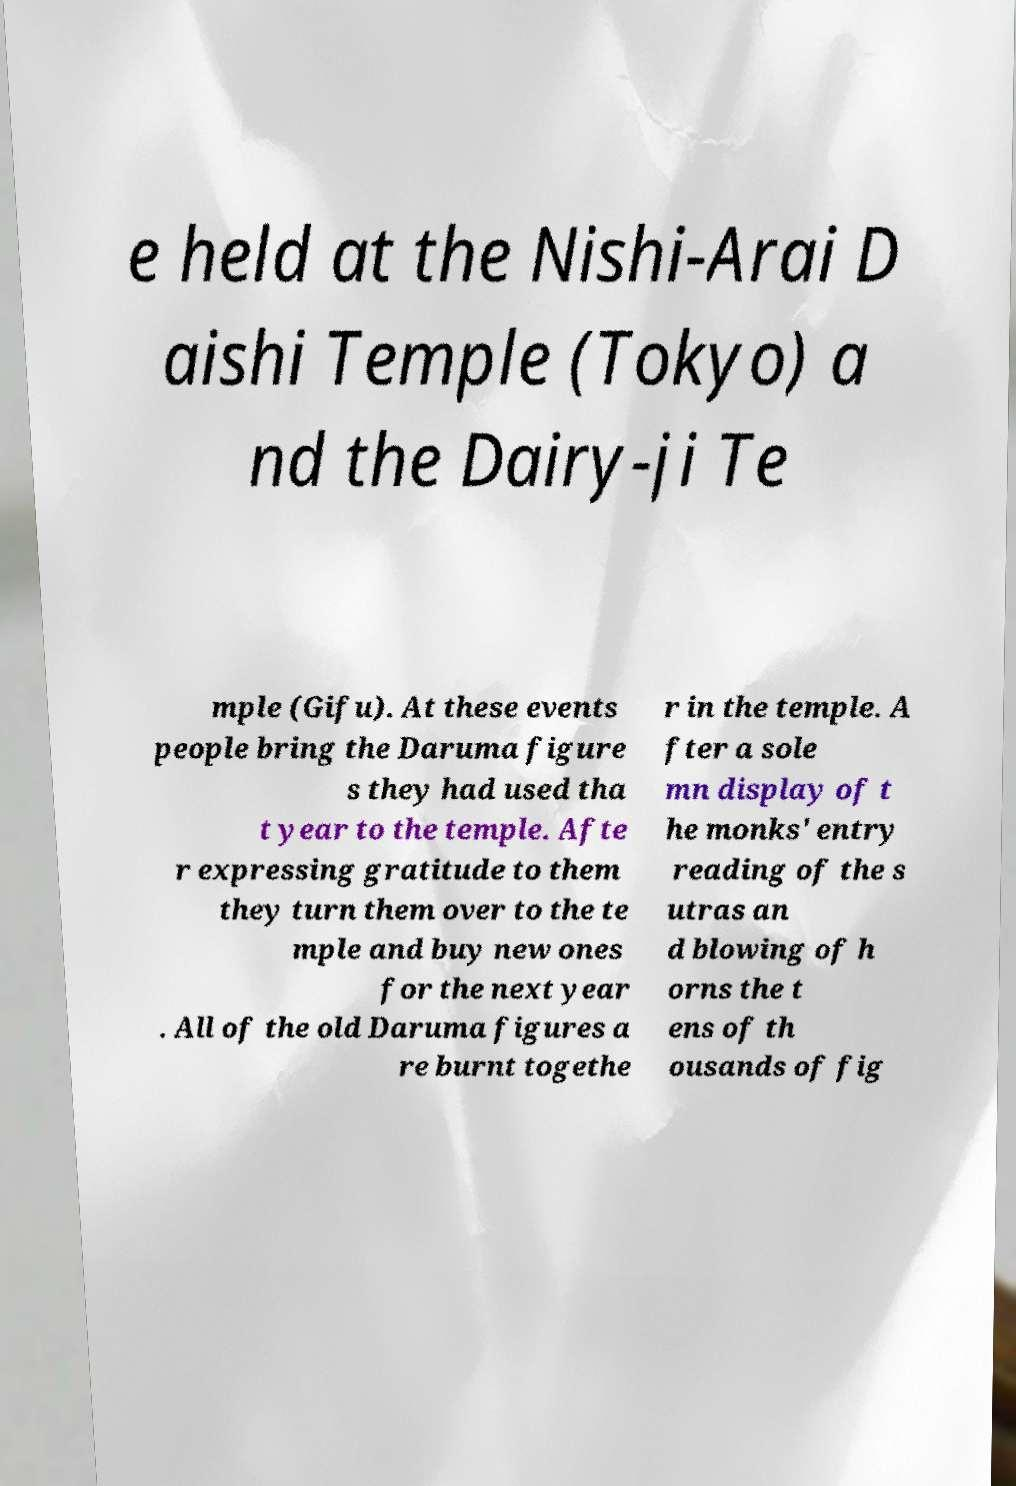Please identify and transcribe the text found in this image. e held at the Nishi-Arai D aishi Temple (Tokyo) a nd the Dairy-ji Te mple (Gifu). At these events people bring the Daruma figure s they had used tha t year to the temple. Afte r expressing gratitude to them they turn them over to the te mple and buy new ones for the next year . All of the old Daruma figures a re burnt togethe r in the temple. A fter a sole mn display of t he monks' entry reading of the s utras an d blowing of h orns the t ens of th ousands of fig 